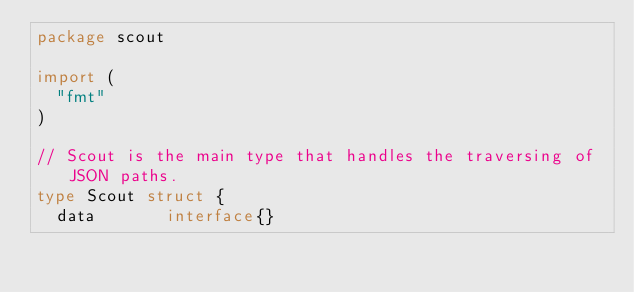<code> <loc_0><loc_0><loc_500><loc_500><_Go_>package scout

import (
	"fmt"
)

// Scout is the main type that handles the traversing of JSON paths.
type Scout struct {
	data       interface{}</code> 